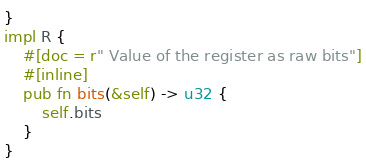Convert code to text. <code><loc_0><loc_0><loc_500><loc_500><_Rust_>}
impl R {
    #[doc = r" Value of the register as raw bits"]
    #[inline]
    pub fn bits(&self) -> u32 {
        self.bits
    }
}
</code> 